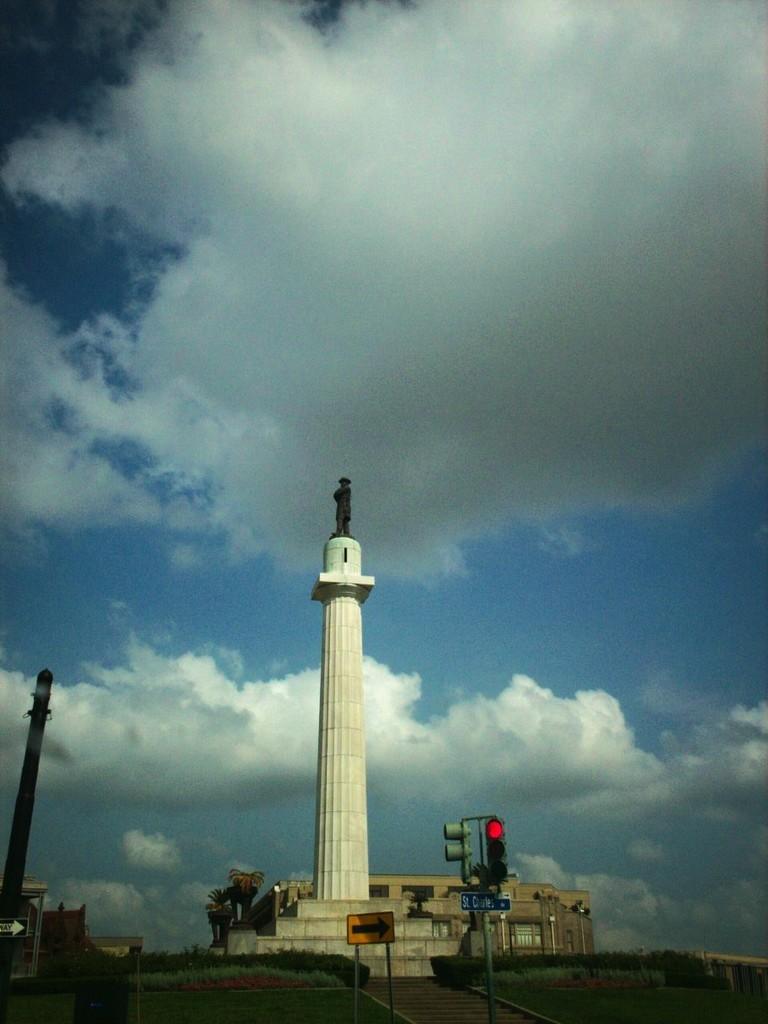In one or two sentences, can you explain what this image depicts? This image is taken outdoors. At the top of the image there is a sky with clouds. At the bottom of the image there is a road and there are a few signboards and a street light. There are few trees, plants and a building in the background. In the middle of the image there is a tower and there is a statue on the tower. 